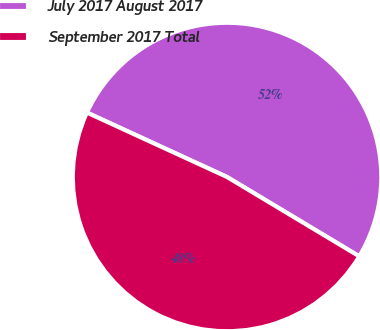Convert chart. <chart><loc_0><loc_0><loc_500><loc_500><pie_chart><fcel>July 2017 August 2017<fcel>September 2017 Total<nl><fcel>51.74%<fcel>48.26%<nl></chart> 